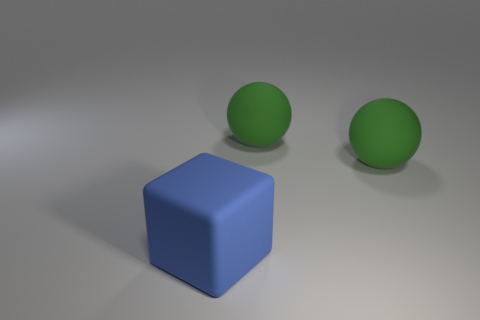How many things are either large blue objects or big objects right of the large rubber block?
Provide a succinct answer. 3. How many matte objects are large blue objects or green spheres?
Provide a succinct answer. 3. Is the number of green matte spheres that are behind the large rubber block greater than the number of yellow rubber cubes?
Your response must be concise. Yes. How many other things are there of the same material as the blue block?
Provide a succinct answer. 2. What number of tiny things are green objects or matte objects?
Your answer should be compact. 0. Are there any red shiny cylinders that have the same size as the blue rubber cube?
Ensure brevity in your answer.  No. What is the material of the big block?
Your response must be concise. Rubber. What number of other large rubber cubes are the same color as the matte block?
Give a very brief answer. 0. What number of objects are things behind the big cube or blue matte objects?
Your answer should be compact. 3. What number of objects are either things that are right of the cube or large green objects that are behind the matte block?
Provide a short and direct response. 2. 